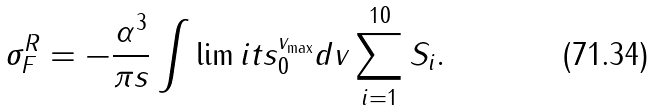<formula> <loc_0><loc_0><loc_500><loc_500>\sigma ^ { R } _ { F } = - \frac { \alpha ^ { 3 } } { \pi s } \int \lim i t s _ { 0 } ^ { v _ { \max } } d v \sum _ { i = 1 } ^ { 1 0 } S _ { i } .</formula> 